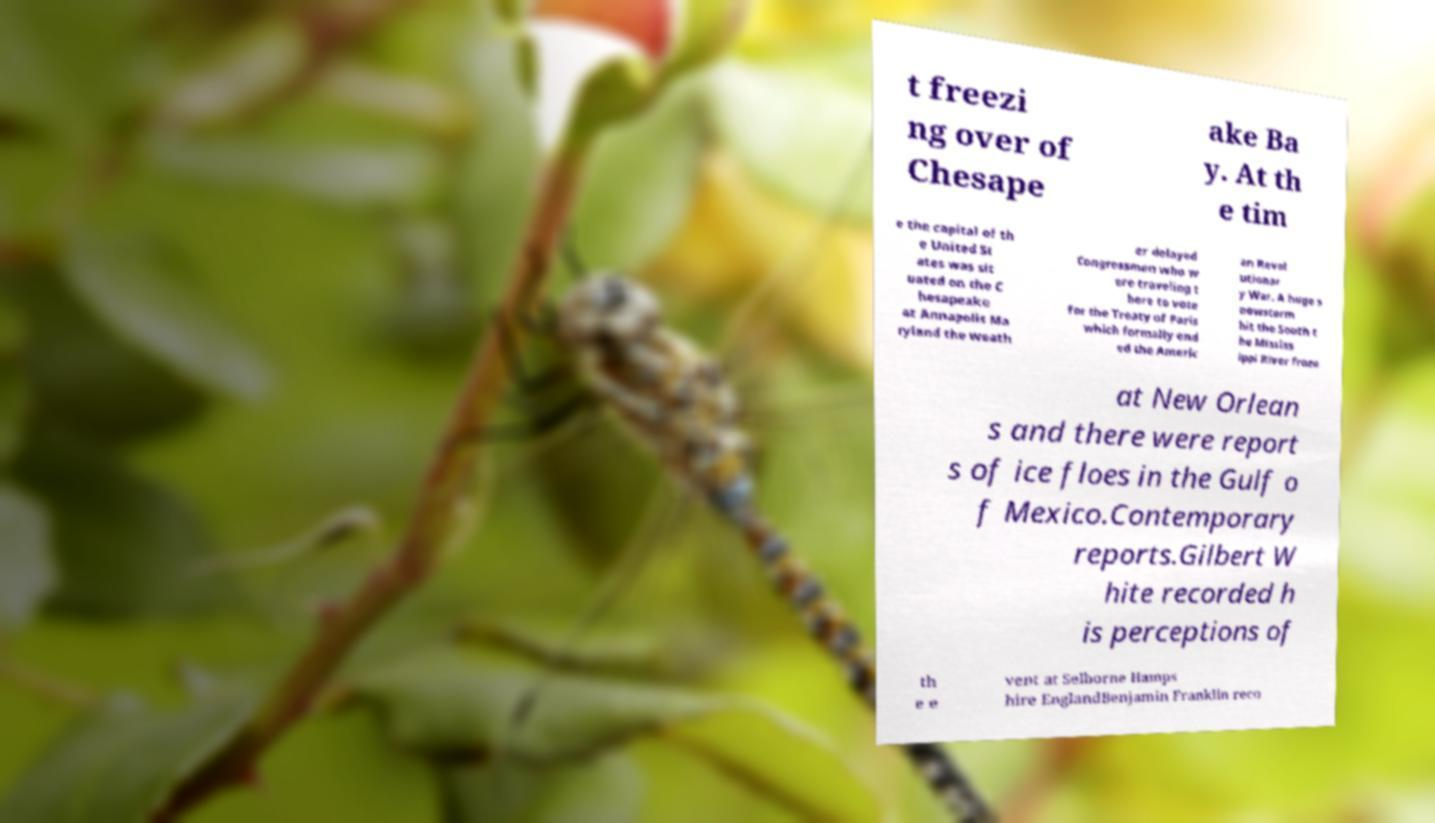Please identify and transcribe the text found in this image. t freezi ng over of Chesape ake Ba y. At th e tim e the capital of th e United St ates was sit uated on the C hesapeake at Annapolis Ma ryland the weath er delayed Congressmen who w ere traveling t here to vote for the Treaty of Paris which formally end ed the Americ an Revol utionar y War. A huge s nowstorm hit the South t he Mississ ippi River froze at New Orlean s and there were report s of ice floes in the Gulf o f Mexico.Contemporary reports.Gilbert W hite recorded h is perceptions of th e e vent at Selborne Hamps hire EnglandBenjamin Franklin reco 